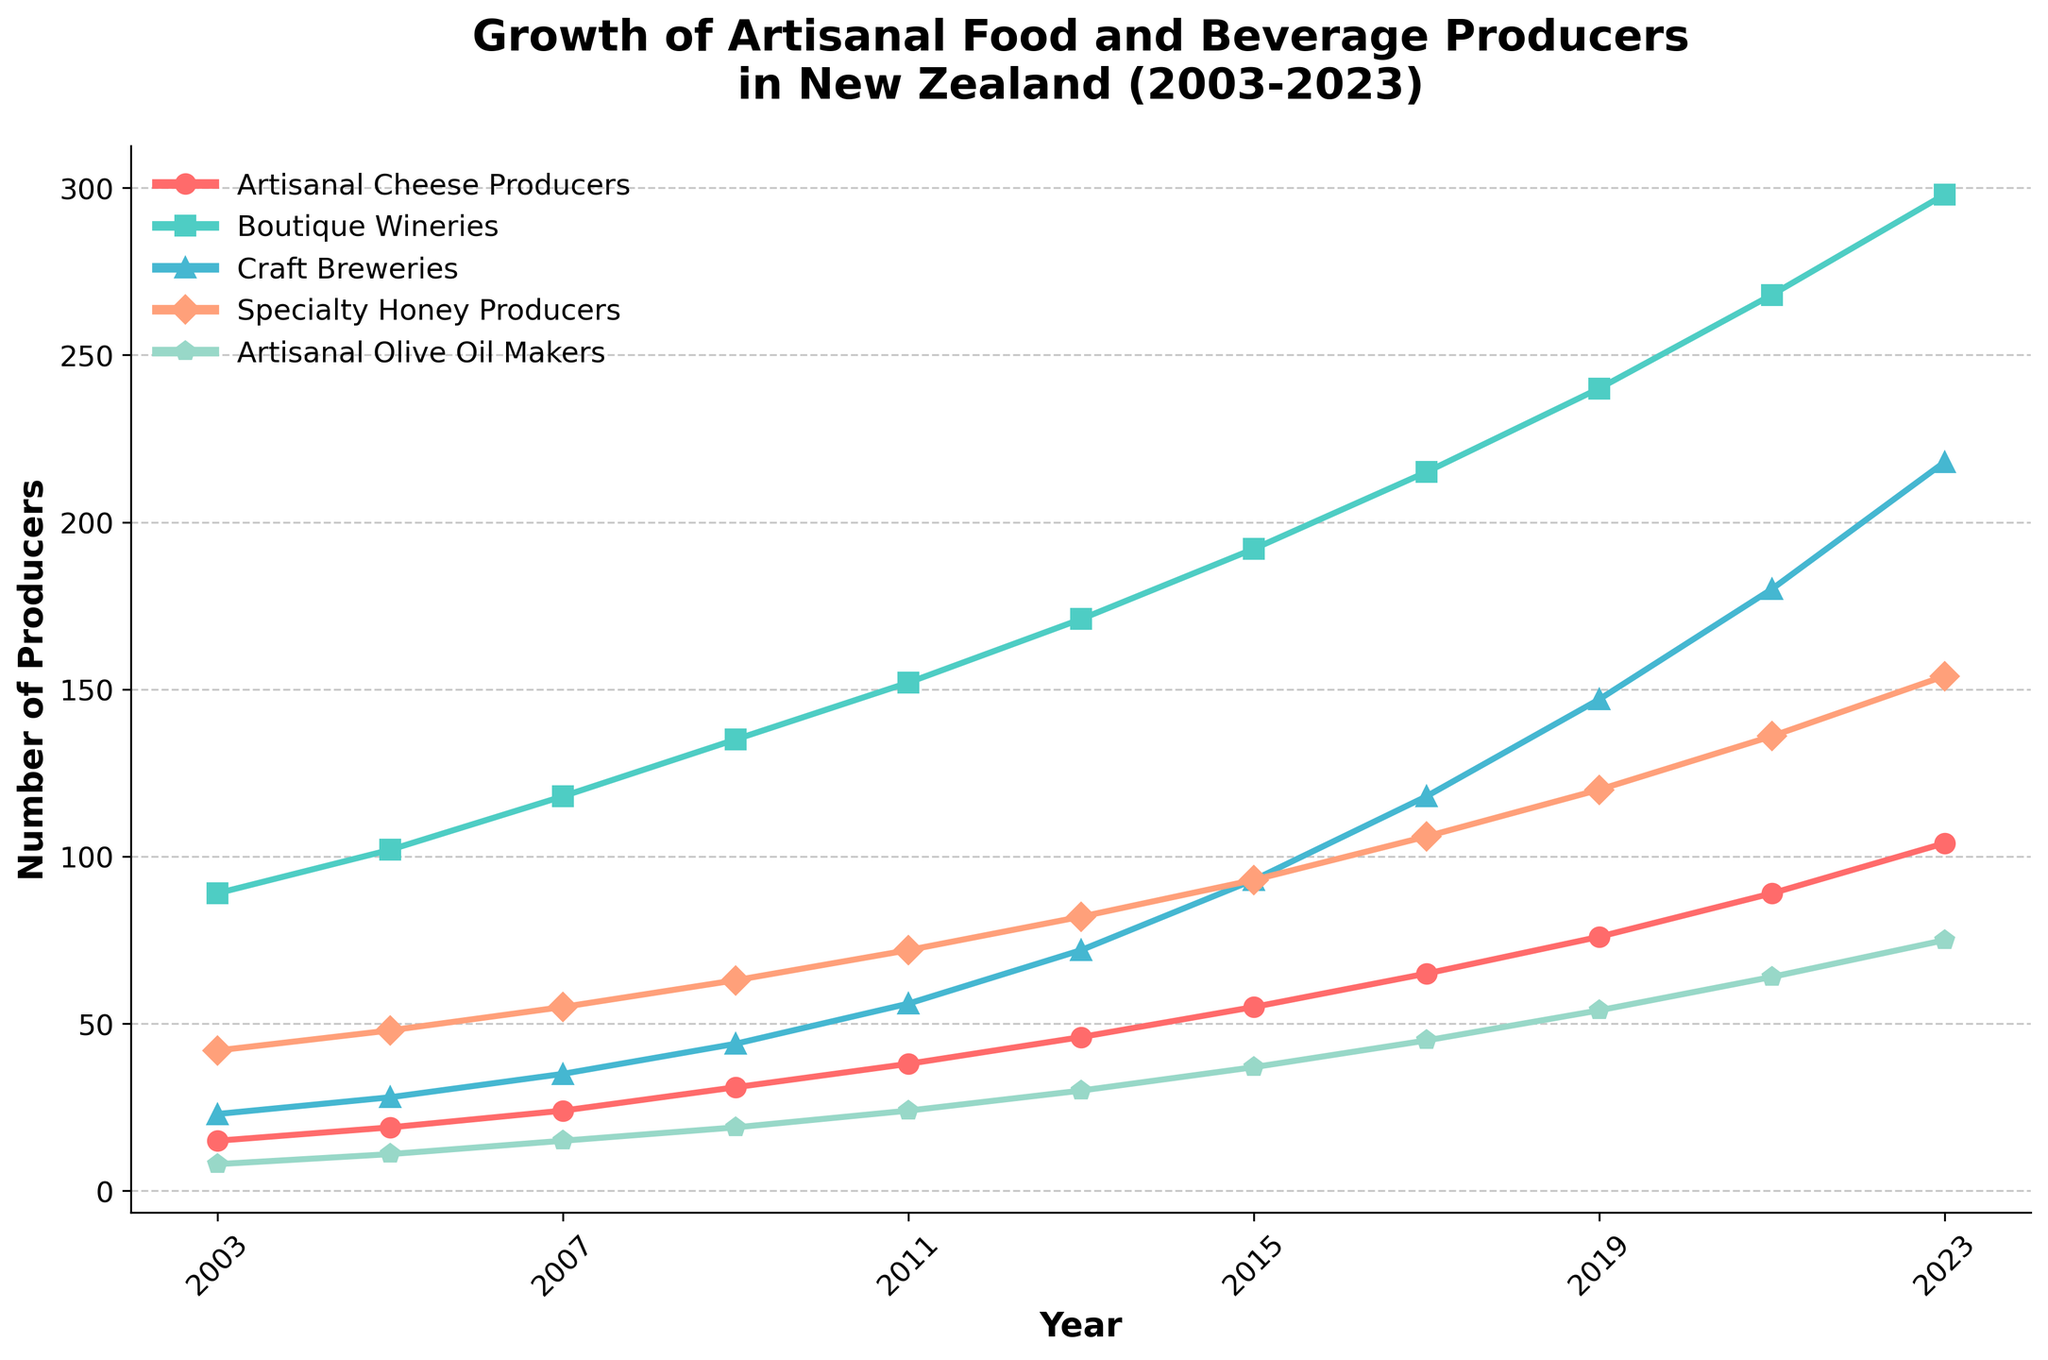What is the overall trend in the number of artisanal cheese producers from 2003 to 2023? The number of artisanal cheese producers consistently increases over the 20-year period, going from 15 in 2003 to 104 in 2023.
Answer: Increasing Between boutique wineries and craft breweries, which had a higher number of producers in 2023? In 2023, the number of boutique wineries was 298 and the number of craft breweries was 218. Therefore, boutique wineries had more producers.
Answer: Boutique wineries By how much did the number of specialty honey producers increase from 2003 to 2023? Subtract the number of specialty honey producers in 2003 (42) from that in 2023 (154): 154 - 42 = 112.
Answer: 112 Which category saw the highest growth rate in the 20-year period reflected in the chart? From 2003 to 2023, compare the increase for each category: 
- Artisanal Cheese Producers: 104-15 = 89
- Boutique Wineries: 298-89 = 209
- Craft Breweries: 218-23 = 195
- Specialty Honey Producers: 154-42 = 112
- Artisanal Olive Oil Makers: 75-8 = 67
Boutique Wineries had the highest growth (209).
Answer: Boutique Wineries What is the difference in the number of craft breweries and artisanal olive oil makers in 2021? In 2021, the number of craft breweries is 180, and the number of artisanal olive oil makers is 64. Subtract 64 from 180: 180 - 64 = 116.
Answer: 116 Among all the categories, which had the lowest number of producers in 2009? The numbers in 2009 are: 
- Artisanal Cheese Producers: 31
- Boutique Wineries: 135
- Craft Breweries: 44
- Specialty Honey Producers: 63
- Artisanal Olive Oil Makers: 19
Artisanal Olive Oil Makers had the lowest number with 19 producers.
Answer: Artisanal Olive Oil Makers What was the average number of craft breweries from 2003 to 2023? Sum the numbers from each year (23, 28, 35, 44, 56, 72, 93, 118, 147, 180, 218) and divide by the number of data points (11): (23+28+35+44+56+72+93+118+147+180+218)/11 = 99.
Answer: 99 From 2015 to 2023, which category had the most significant increase in the number of producers? Compare the increases from 2015 to 2023:
- Artisanal Cheese Producers: 104-55 = 49
- Boutique Wineries: 298-192 = 106
- Craft Breweries: 218-93 = 125
- Specialty Honey Producers: 154-93 = 61
- Artisanal Olive Oil Makers: 75-37 = 38
Craft Breweries had the most significant increase with 125.
Answer: Craft Breweries In which year did specialty honey producers surpass 100 producers for the first time? Observe the values: in 2017 (106), the number of specialty honey producers surpasses 100 for the first time.
Answer: 2017 